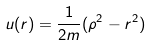Convert formula to latex. <formula><loc_0><loc_0><loc_500><loc_500>u ( r ) = \frac { 1 } { 2 m } ( \rho ^ { 2 } - r ^ { 2 } )</formula> 